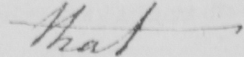Transcribe the text shown in this historical manuscript line. that 